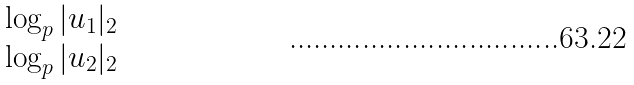<formula> <loc_0><loc_0><loc_500><loc_500>\begin{matrix} \log _ { p } | u _ { 1 } | _ { 2 } \\ \log _ { p } | u _ { 2 } | _ { 2 } \end{matrix}</formula> 